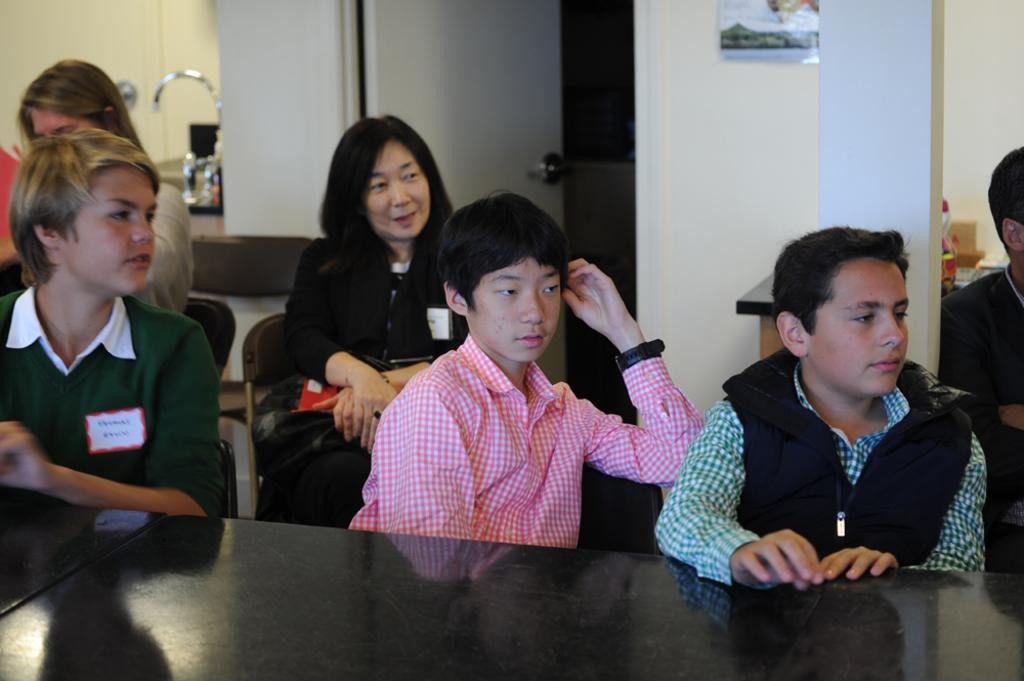What are the persons in the image doing? The persons in the image are sitting on chairs. What is located at the bottom of the image? There is a table at the bottom of the image. What can be seen in the background of the image? There is a door, a sink, a tap, a pillar, and a wall in the background of the image. How many boys are trading pies in the image? There are no boys or pies present in the image. What type of pie is being served at the table in the image? There is no pie present in the image; only a table can be seen at the bottom of the image. 